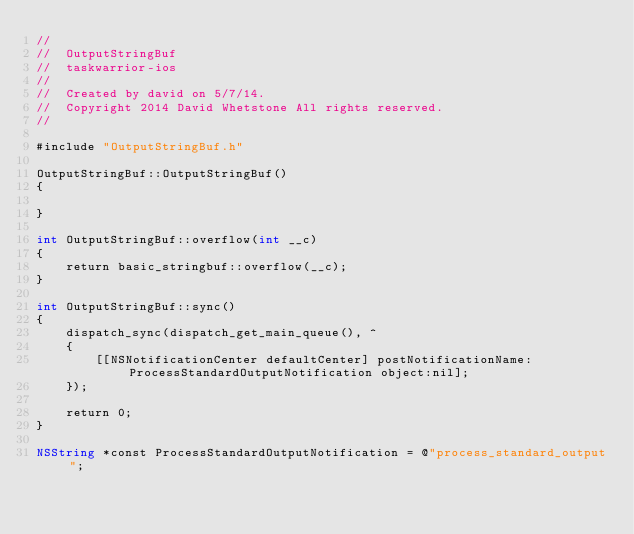<code> <loc_0><loc_0><loc_500><loc_500><_ObjectiveC_>//
//  OutputStringBuf
//  taskwarrior-ios
//
//  Created by david on 5/7/14.
//  Copyright 2014 David Whetstone All rights reserved.
//

#include "OutputStringBuf.h"

OutputStringBuf::OutputStringBuf()
{

}

int OutputStringBuf::overflow(int __c)
{
    return basic_stringbuf::overflow(__c);
}

int OutputStringBuf::sync()
{
    dispatch_sync(dispatch_get_main_queue(), ^
    {
        [[NSNotificationCenter defaultCenter] postNotificationName:ProcessStandardOutputNotification object:nil];
    });

    return 0;
}

NSString *const ProcessStandardOutputNotification = @"process_standard_output";
</code> 